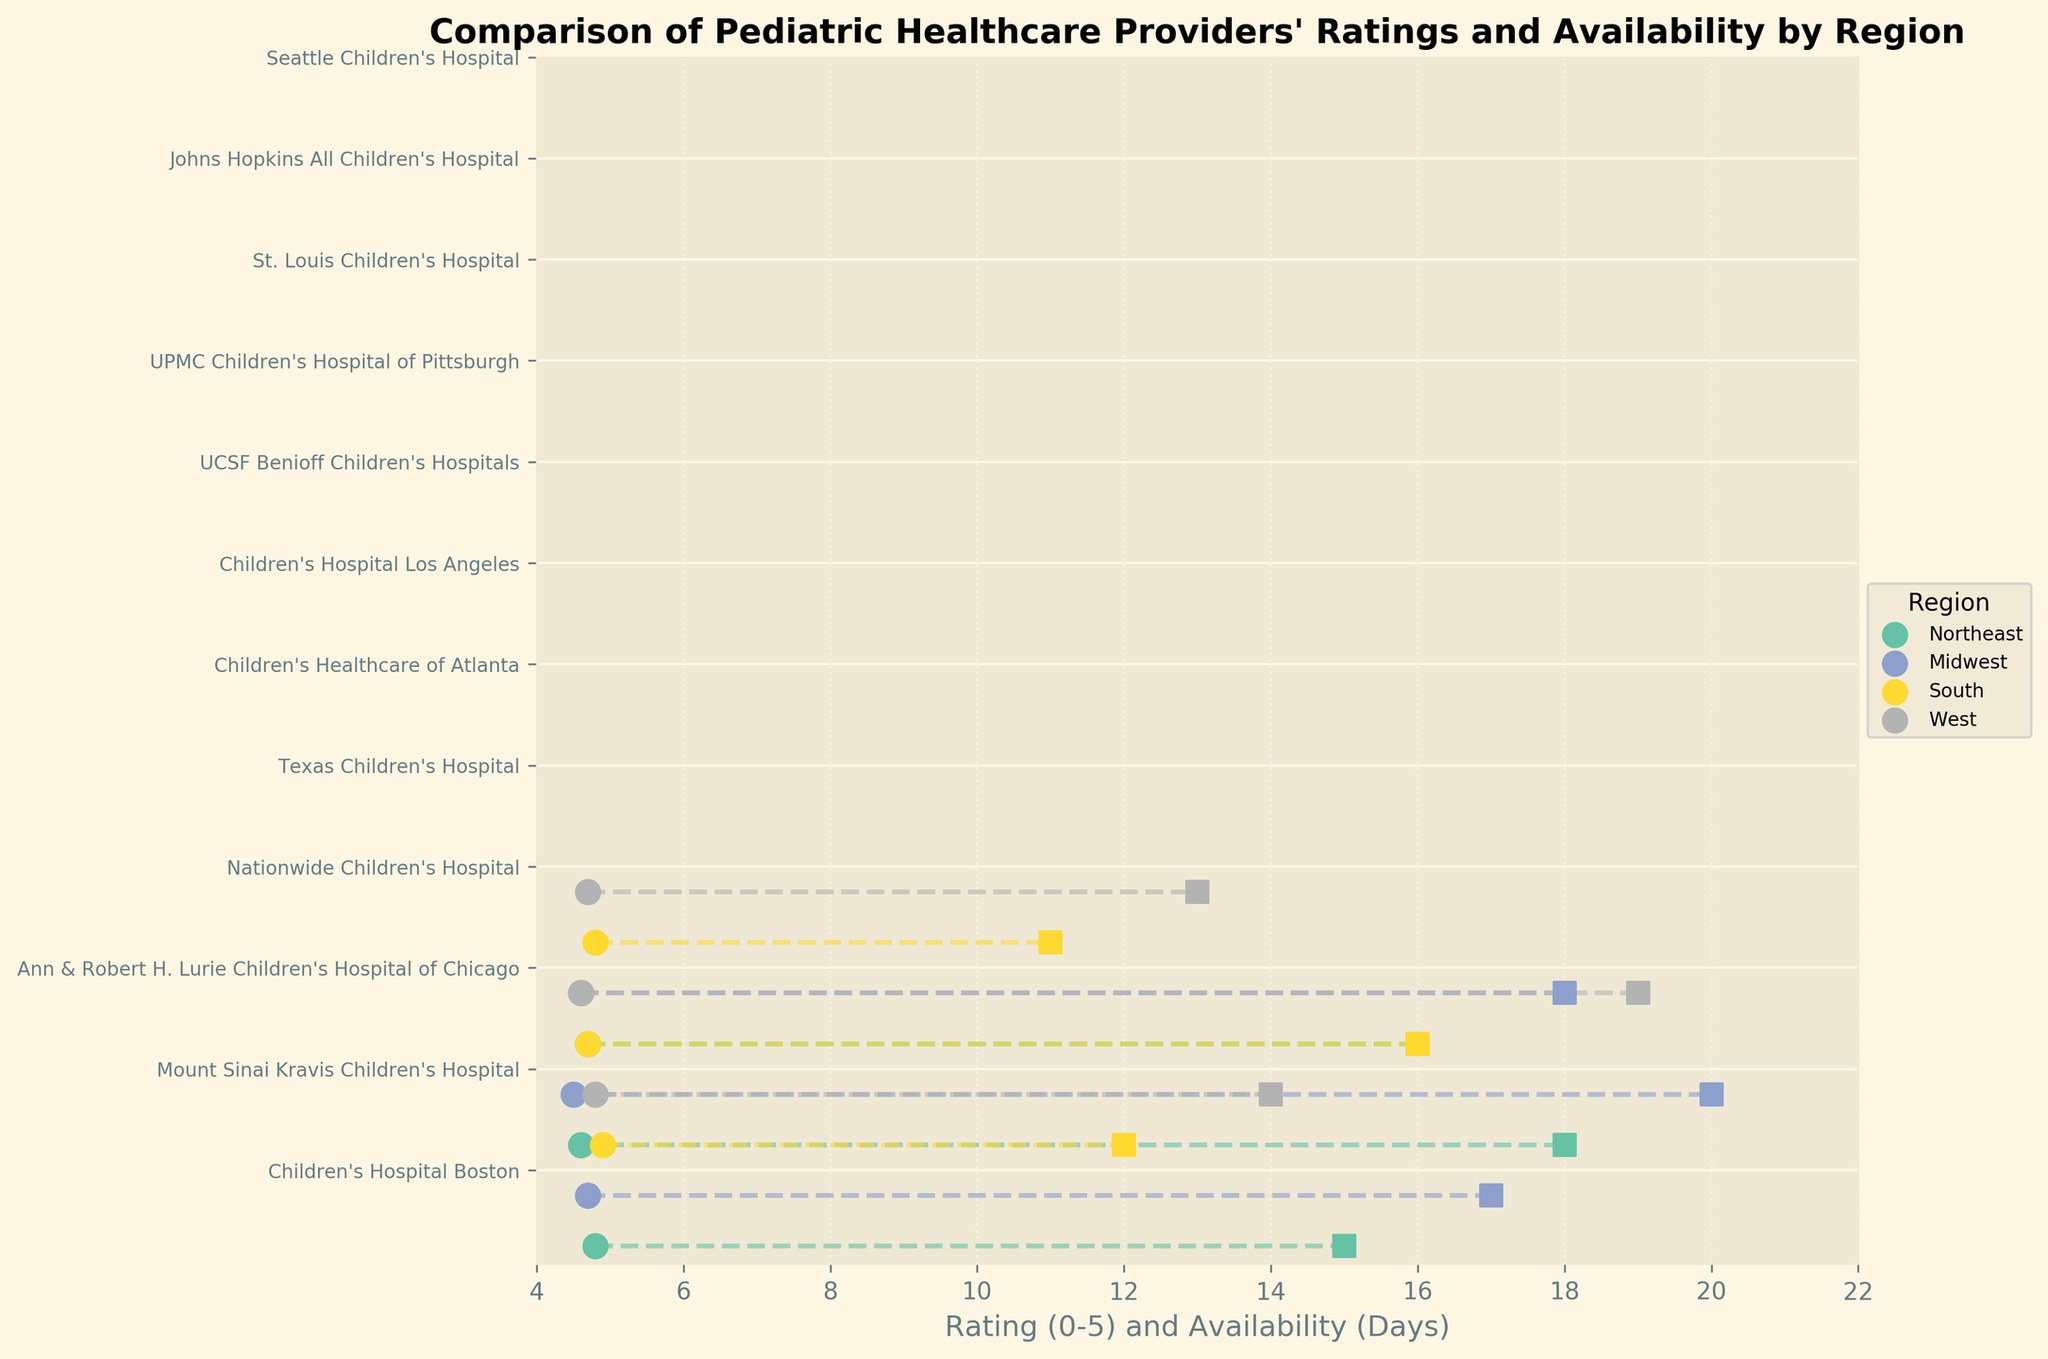How many regions are represented in the plot? There are four unique colors in the plot, each corresponding to a different region.
Answer: 4 Which pediatric healthcare provider has the highest rating? By looking at the maximum value in the rating axis, Texas Children's Hospital in the South has the highest rating of 4.9.
Answer: Texas Children's Hospital What region has the pediatric healthcare providers with the shortest availability days? The region color for the shortest availability days (11 and 12 days) belongs to the South region.
Answer: South What is the combined average rating of the healthcare providers in the Northeast region? The providers in the Northeast region have ratings of 4.8, 4.6, and 4.7. Adding these (4.8 + 4.6 + 4.7) gives 14.1, and dividing by 3 gives approximately 4.7.
Answer: 4.7 Compare the availability days of Seattle Children's Hospital and UCSF Benioff Children's Hospitals. Which one has lesser days and by how many? Seattle Children's Hospital has an availability of 13 days, while UCSF Benioff Children's Hospitals has 19 days. The difference is 19 - 13 = 6 days.
Answer: Seattle Children's Hospital, by 6 days Which pediatric healthcare provider demonstrates both a high rating and quick availability? Johns Hopkins All Children's Hospital in the South region has a high rating of 4.8 and quick availability with just 11 days.
Answer: Johns Hopkins All Children's Hospital What is the average availability (days to new appointment) of the healthcare providers in the Midwest region? The providers in the Midwest region have availability of 17, 20, and 18. Adding these (17 + 20 + 18) gives 55, and dividing by 3 gives approximately 18.3 days.
Answer: 18.3 days Identify the pediatric healthcare provider in the West region with the highest rating. What is its rating? Among the West region providers, Children's Hospital Los Angeles has the highest rating of 4.8.
Answer: Children's Hospital Los Angeles, 4.8 